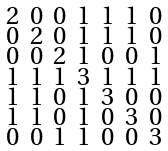<formula> <loc_0><loc_0><loc_500><loc_500>\begin{smallmatrix} 2 & 0 & 0 & 1 & 1 & 1 & 0 \\ 0 & 2 & 0 & 1 & 1 & 1 & 0 \\ 0 & 0 & 2 & 1 & 0 & 0 & 1 \\ 1 & 1 & 1 & 3 & 1 & 1 & 1 \\ 1 & 1 & 0 & 1 & 3 & 0 & 0 \\ 1 & 1 & 0 & 1 & 0 & 3 & 0 \\ 0 & 0 & 1 & 1 & 0 & 0 & 3 \end{smallmatrix}</formula> 